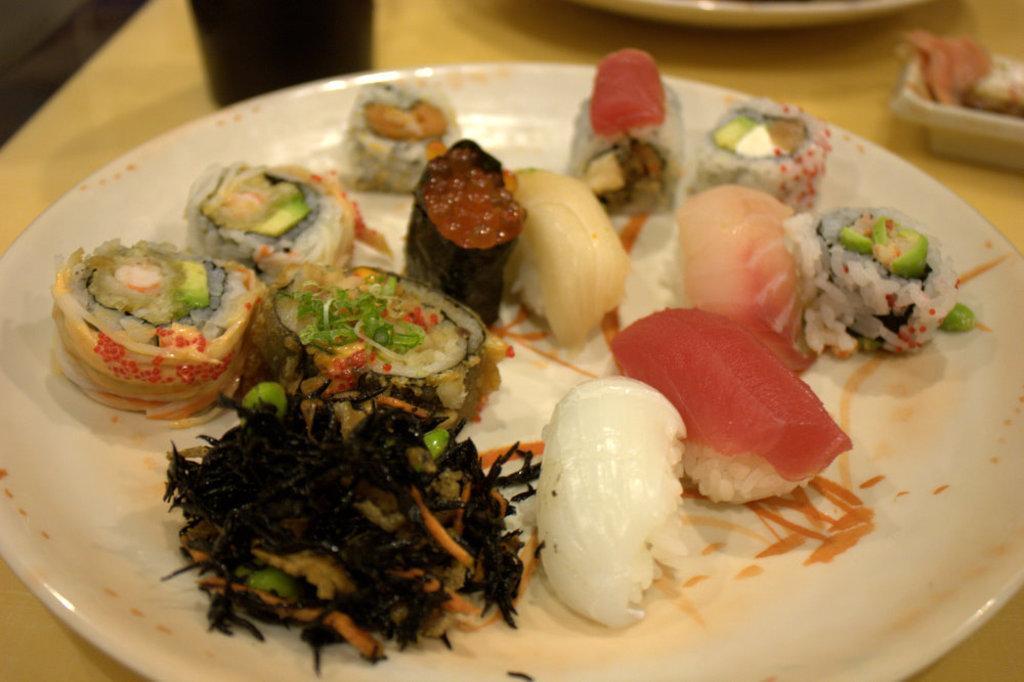Please provide a concise description of this image. In the center of the image there is a table. On the table we can see a food items is present on the plate. 